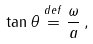Convert formula to latex. <formula><loc_0><loc_0><loc_500><loc_500>\tan \theta \stackrel { d e f } { = } \frac { \omega } { a } \, ,</formula> 